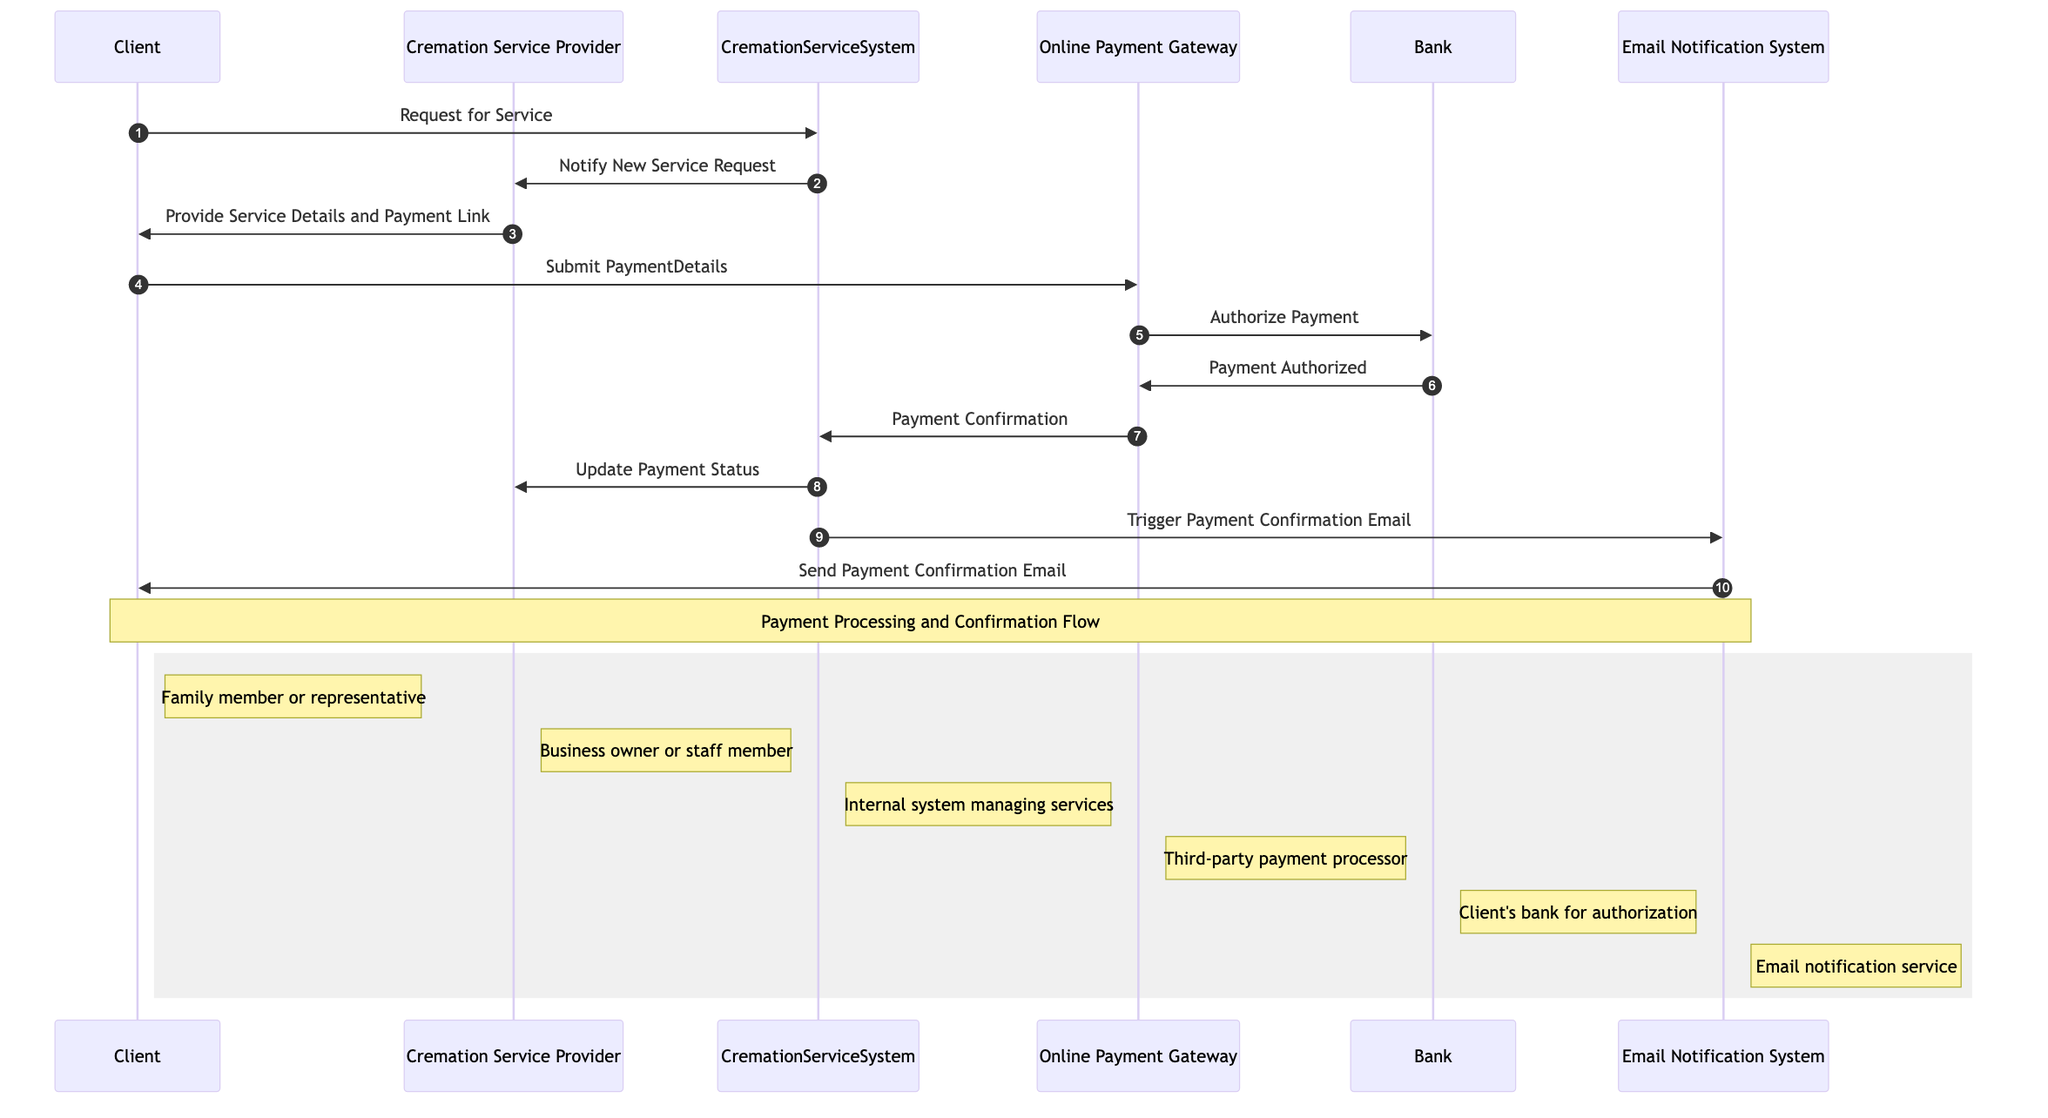What is the first action in the sequence diagram? The first action is initiated by the Client who makes a "Request for Service" to the CremationServiceSystem. This action is the starting point of the entire payment processing flow depicted in the sequence diagram.
Answer: Request for Service How many actors are involved in the diagram? The diagram features a total of five distinct actors: Client, Cremation Service Provider, Online Payment Gateway, Bank, and Email Notification System. By counting each of them listed in the diagram, we confirm their presence.
Answer: Five What message does the CremationServiceSystem send to the Cremation Service Provider? The message sent is "Notify New Service Request." This communication informs the provider of a new client request, which is crucial for monitoring and managing service orders.
Answer: Notify New Service Request What does the Online Payment Gateway do after authorizing the payment? After authorizing the payment, the Online Payment Gateway sends a "Payment Confirmation" message to the CremationServiceSystem. This step is essential to continue processing within the internal system after the payment is validated.
Answer: Payment Confirmation Which actor is responsible for sending the payment confirmation email to the Client? The Email Notification System is responsible for sending the "Send Payment Confirmation Email" to the Client after receiving payment details from the CremationServiceSystem. This ensures that the Client receives confirmation of their transaction.
Answer: Email Notification System What action follows the Client submitting the payment details? The action that follows is the Online Payment Gateway's task to "Authorize Payment" by forwards the payment information to the Bank for verification. This sequence step is part of the payment validation process.
Answer: Authorize Payment How many messages are sent from the CremationServiceSystem to the Email Notification System? There is one message sent from the CremationServiceSystem, which is "Trigger Payment Confirmation Email," initiating the notification process for the Client. This shows the communication pathway between these two components regarding payment confirmation.
Answer: One What is the role of the Bank in this sequence? The Bank's role is to authorize the payment by validating the transaction details received from the Online Payment Gateway. It acts as the intermediary that ensures funds are available and approves the payment process.
Answer: Authorize Payment What does the Cremation Service Provider provide to the Client? The Cremation Service Provider provides "Service Details and Payment Link" to the Client. This essential information is crucial for the Client to proceed with the payment after understanding the service offered.
Answer: Service Details and Payment Link 